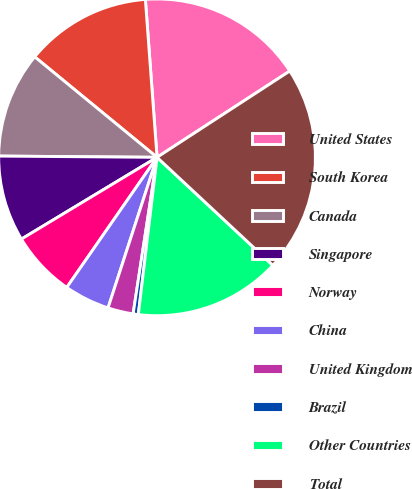<chart> <loc_0><loc_0><loc_500><loc_500><pie_chart><fcel>United States<fcel>South Korea<fcel>Canada<fcel>Singapore<fcel>Norway<fcel>China<fcel>United Kingdom<fcel>Brazil<fcel>Other Countries<fcel>Total<nl><fcel>17.0%<fcel>12.88%<fcel>10.82%<fcel>8.76%<fcel>6.71%<fcel>4.65%<fcel>2.59%<fcel>0.53%<fcel>14.94%<fcel>21.12%<nl></chart> 